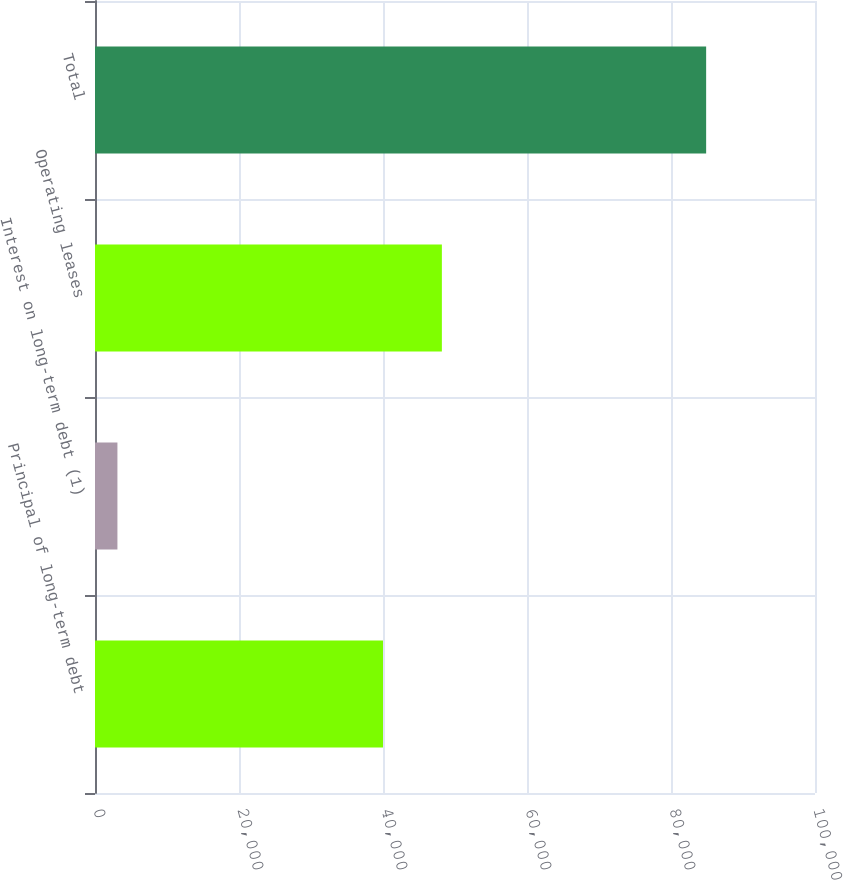Convert chart. <chart><loc_0><loc_0><loc_500><loc_500><bar_chart><fcel>Principal of long-term debt<fcel>Interest on long-term debt (1)<fcel>Operating leases<fcel>Total<nl><fcel>40000<fcel>3115<fcel>48176.6<fcel>84881<nl></chart> 